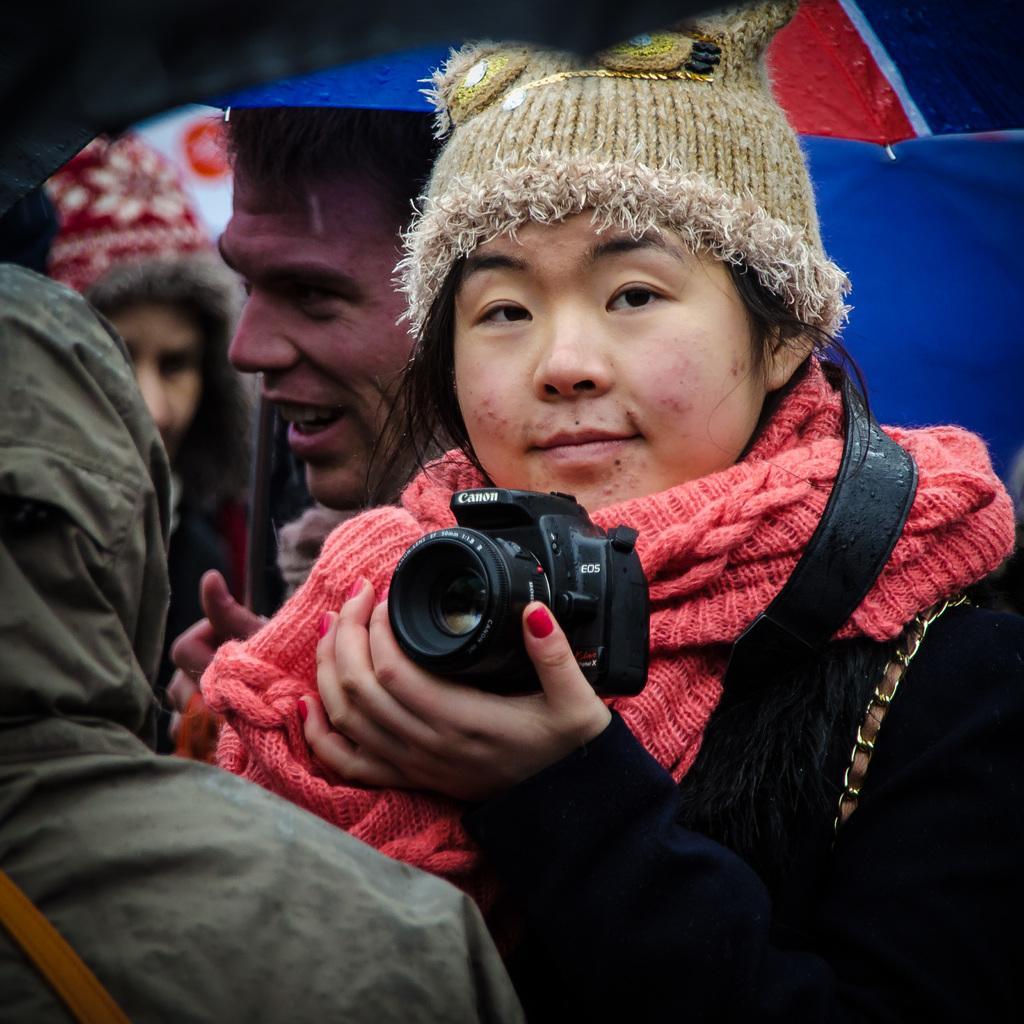Can you describe this image briefly? A lady is holding a camera in one of her hands and there are few people in the background of the image. 